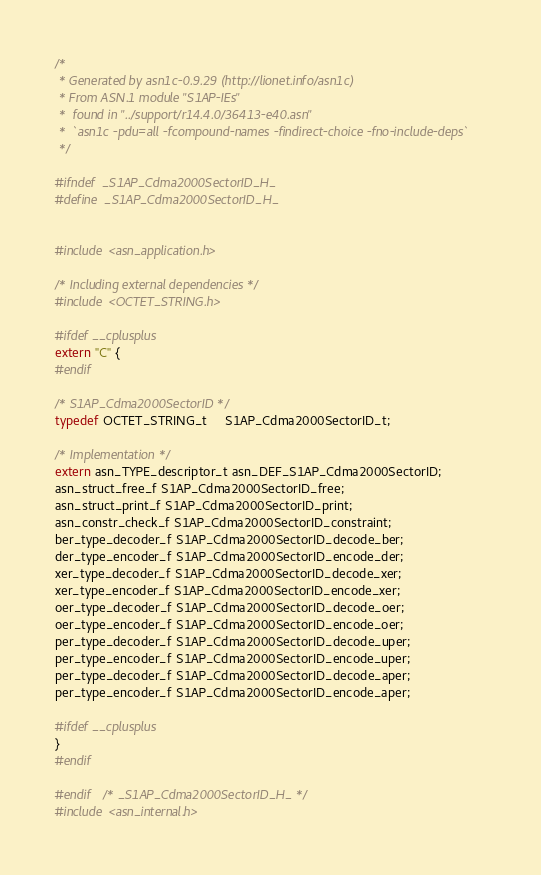Convert code to text. <code><loc_0><loc_0><loc_500><loc_500><_C_>/*
 * Generated by asn1c-0.9.29 (http://lionet.info/asn1c)
 * From ASN.1 module "S1AP-IEs"
 * 	found in "../support/r14.4.0/36413-e40.asn"
 * 	`asn1c -pdu=all -fcompound-names -findirect-choice -fno-include-deps`
 */

#ifndef	_S1AP_Cdma2000SectorID_H_
#define	_S1AP_Cdma2000SectorID_H_


#include <asn_application.h>

/* Including external dependencies */
#include <OCTET_STRING.h>

#ifdef __cplusplus
extern "C" {
#endif

/* S1AP_Cdma2000SectorID */
typedef OCTET_STRING_t	 S1AP_Cdma2000SectorID_t;

/* Implementation */
extern asn_TYPE_descriptor_t asn_DEF_S1AP_Cdma2000SectorID;
asn_struct_free_f S1AP_Cdma2000SectorID_free;
asn_struct_print_f S1AP_Cdma2000SectorID_print;
asn_constr_check_f S1AP_Cdma2000SectorID_constraint;
ber_type_decoder_f S1AP_Cdma2000SectorID_decode_ber;
der_type_encoder_f S1AP_Cdma2000SectorID_encode_der;
xer_type_decoder_f S1AP_Cdma2000SectorID_decode_xer;
xer_type_encoder_f S1AP_Cdma2000SectorID_encode_xer;
oer_type_decoder_f S1AP_Cdma2000SectorID_decode_oer;
oer_type_encoder_f S1AP_Cdma2000SectorID_encode_oer;
per_type_decoder_f S1AP_Cdma2000SectorID_decode_uper;
per_type_encoder_f S1AP_Cdma2000SectorID_encode_uper;
per_type_decoder_f S1AP_Cdma2000SectorID_decode_aper;
per_type_encoder_f S1AP_Cdma2000SectorID_encode_aper;

#ifdef __cplusplus
}
#endif

#endif	/* _S1AP_Cdma2000SectorID_H_ */
#include <asn_internal.h>
</code> 